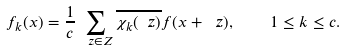Convert formula to latex. <formula><loc_0><loc_0><loc_500><loc_500>f _ { k } ( x ) = \frac { 1 } { c } \sum _ { \ z \in Z } \overline { \chi _ { k } ( \ z ) } f ( x + \ z ) , \quad 1 \leq k \leq c .</formula> 